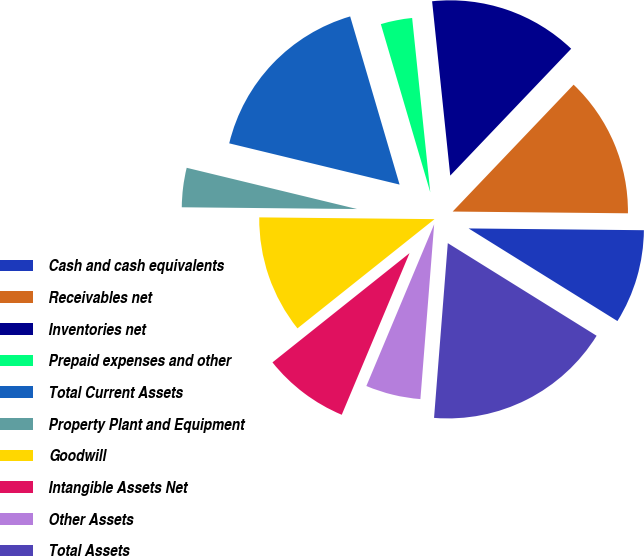Convert chart to OTSL. <chart><loc_0><loc_0><loc_500><loc_500><pie_chart><fcel>Cash and cash equivalents<fcel>Receivables net<fcel>Inventories net<fcel>Prepaid expenses and other<fcel>Total Current Assets<fcel>Property Plant and Equipment<fcel>Goodwill<fcel>Intangible Assets Net<fcel>Other Assets<fcel>Total Assets<nl><fcel>8.7%<fcel>13.04%<fcel>13.77%<fcel>2.9%<fcel>16.67%<fcel>3.62%<fcel>10.87%<fcel>7.97%<fcel>5.07%<fcel>17.39%<nl></chart> 